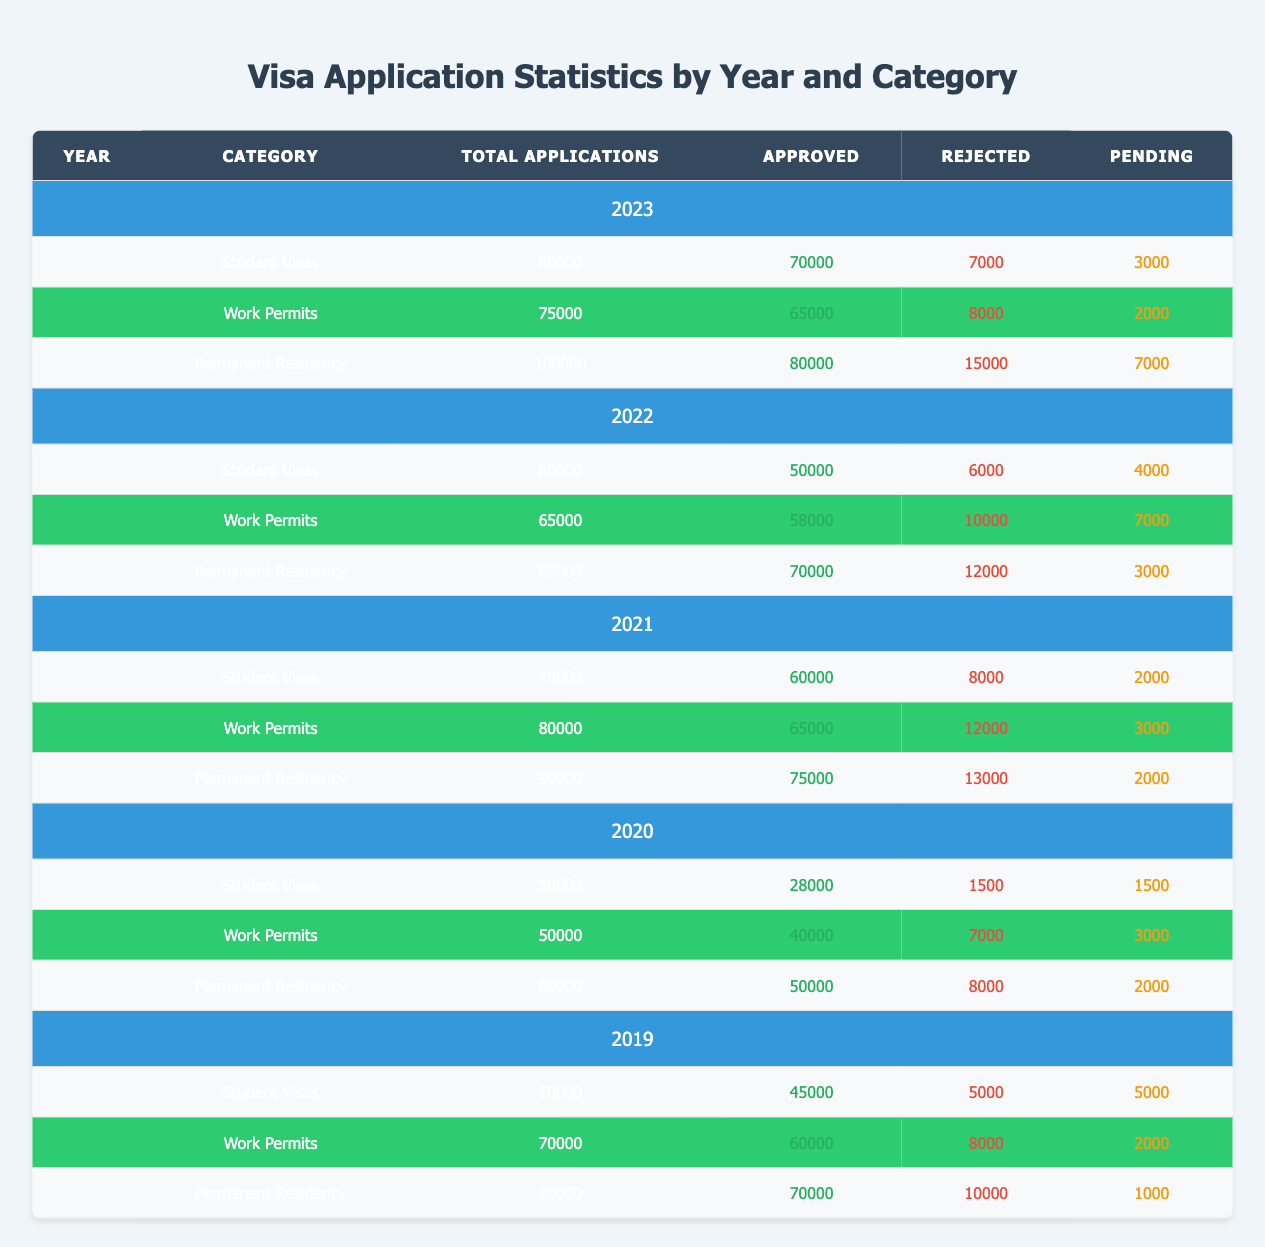What was the total number of approved Work Permits in 2021? In 2021, the number of approved Work Permits is listed under the category "Work Permits" for that year. The table shows that there were 65000 approved applications for Work Permits in 2021.
Answer: 65000 Which year had the highest total applications for Permanent Residency? To find the year with the highest total applications for Permanent Residency, we compare the total applications across years. The values are: 80000 (2019), 60000 (2020), 90000 (2021), 85000 (2022), and 100000 (2023). The year 2023 has the highest total applications at 100000.
Answer: 2023 How many applications for Student Visas were pending in 2022? For 2022, we look for the row corresponding to Student Visas in the table. The pending applications in 2022 for Student Visas is noted as 4000.
Answer: 4000 Did the total number of rejected Work Permits decrease from 2020 to 2021? In 2020, the rejected Work Permits were 7000, and in 2021, they increased to 12000. Thus, the number of rejected Work Permits did not decrease — it actually increased.
Answer: No What was the average number of approved applications for Permanent Residency over the years 2019 to 2023? The approved applications for Permanent Residency are: 70000 (2019), 50000 (2020), 75000 (2021), 70000 (2022), and 80000 (2023). We first sum these numbers: 70000 + 50000 + 75000 + 70000 + 80000 = 345000. Then, we divide by the number of years (5) to find the average: 345000 / 5 = 69000.
Answer: 69000 What percentage of Student Visa applications were approved in 2020? In 2020, the total applications for Student Visas were 30000, with 28000 approved. To find the percentage approved, we use the formula: (Approved / Total Applications) * 100. Therefore, (28000 / 30000) * 100 = 93.33%.
Answer: 93.33% In which category did the number of pending applications reach the highest point in 2023? Looking at the pending applications in 2023, we find: Student Visas = 3000, Work Permits = 2000, and Permanent Residency = 7000. Since 7000 is the highest value, it indicates that Permanent Residency had the most pending applications in 2023.
Answer: Permanent Residency Were there more total applications for Student Visas in 2021 than in 2020? Total applications for Student Visas in 2020 are 30000, while in 2021, they are 70000. Since 70000 is greater than 30000, there were indeed more applications in 2021.
Answer: Yes 